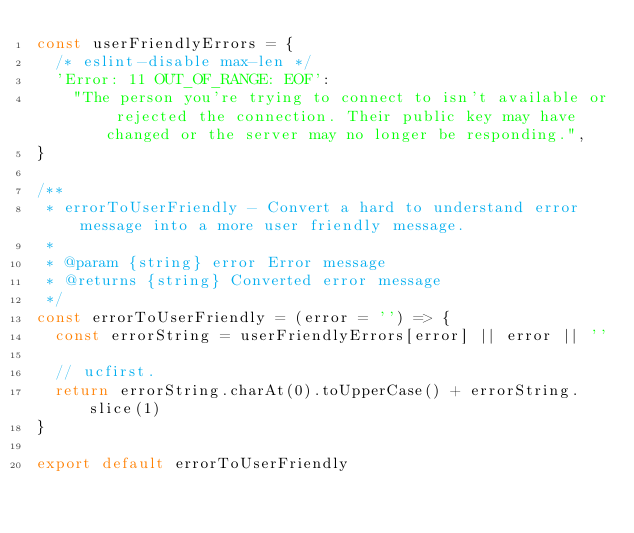Convert code to text. <code><loc_0><loc_0><loc_500><loc_500><_JavaScript_>const userFriendlyErrors = {
  /* eslint-disable max-len */
  'Error: 11 OUT_OF_RANGE: EOF':
    "The person you're trying to connect to isn't available or rejected the connection. Their public key may have changed or the server may no longer be responding.",
}

/**
 * errorToUserFriendly - Convert a hard to understand error message into a more user friendly message.
 *
 * @param {string} error Error message
 * @returns {string} Converted error message
 */
const errorToUserFriendly = (error = '') => {
  const errorString = userFriendlyErrors[error] || error || ''

  // ucfirst.
  return errorString.charAt(0).toUpperCase() + errorString.slice(1)
}

export default errorToUserFriendly
</code> 